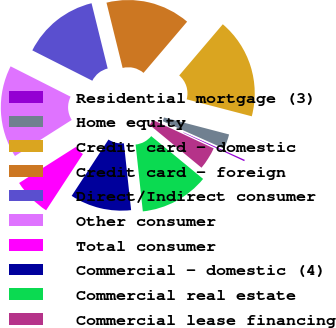Convert chart to OTSL. <chart><loc_0><loc_0><loc_500><loc_500><pie_chart><fcel>Residential mortgage (3)<fcel>Home equity<fcel>Credit card - domestic<fcel>Credit card - foreign<fcel>Direct/Indirect consumer<fcel>Other consumer<fcel>Total consumer<fcel>Commercial - domestic (4)<fcel>Commercial real estate<fcel>Commercial lease financing<nl><fcel>0.25%<fcel>2.64%<fcel>17.84%<fcel>15.08%<fcel>13.69%<fcel>16.46%<fcel>6.78%<fcel>10.93%<fcel>12.31%<fcel>4.02%<nl></chart> 